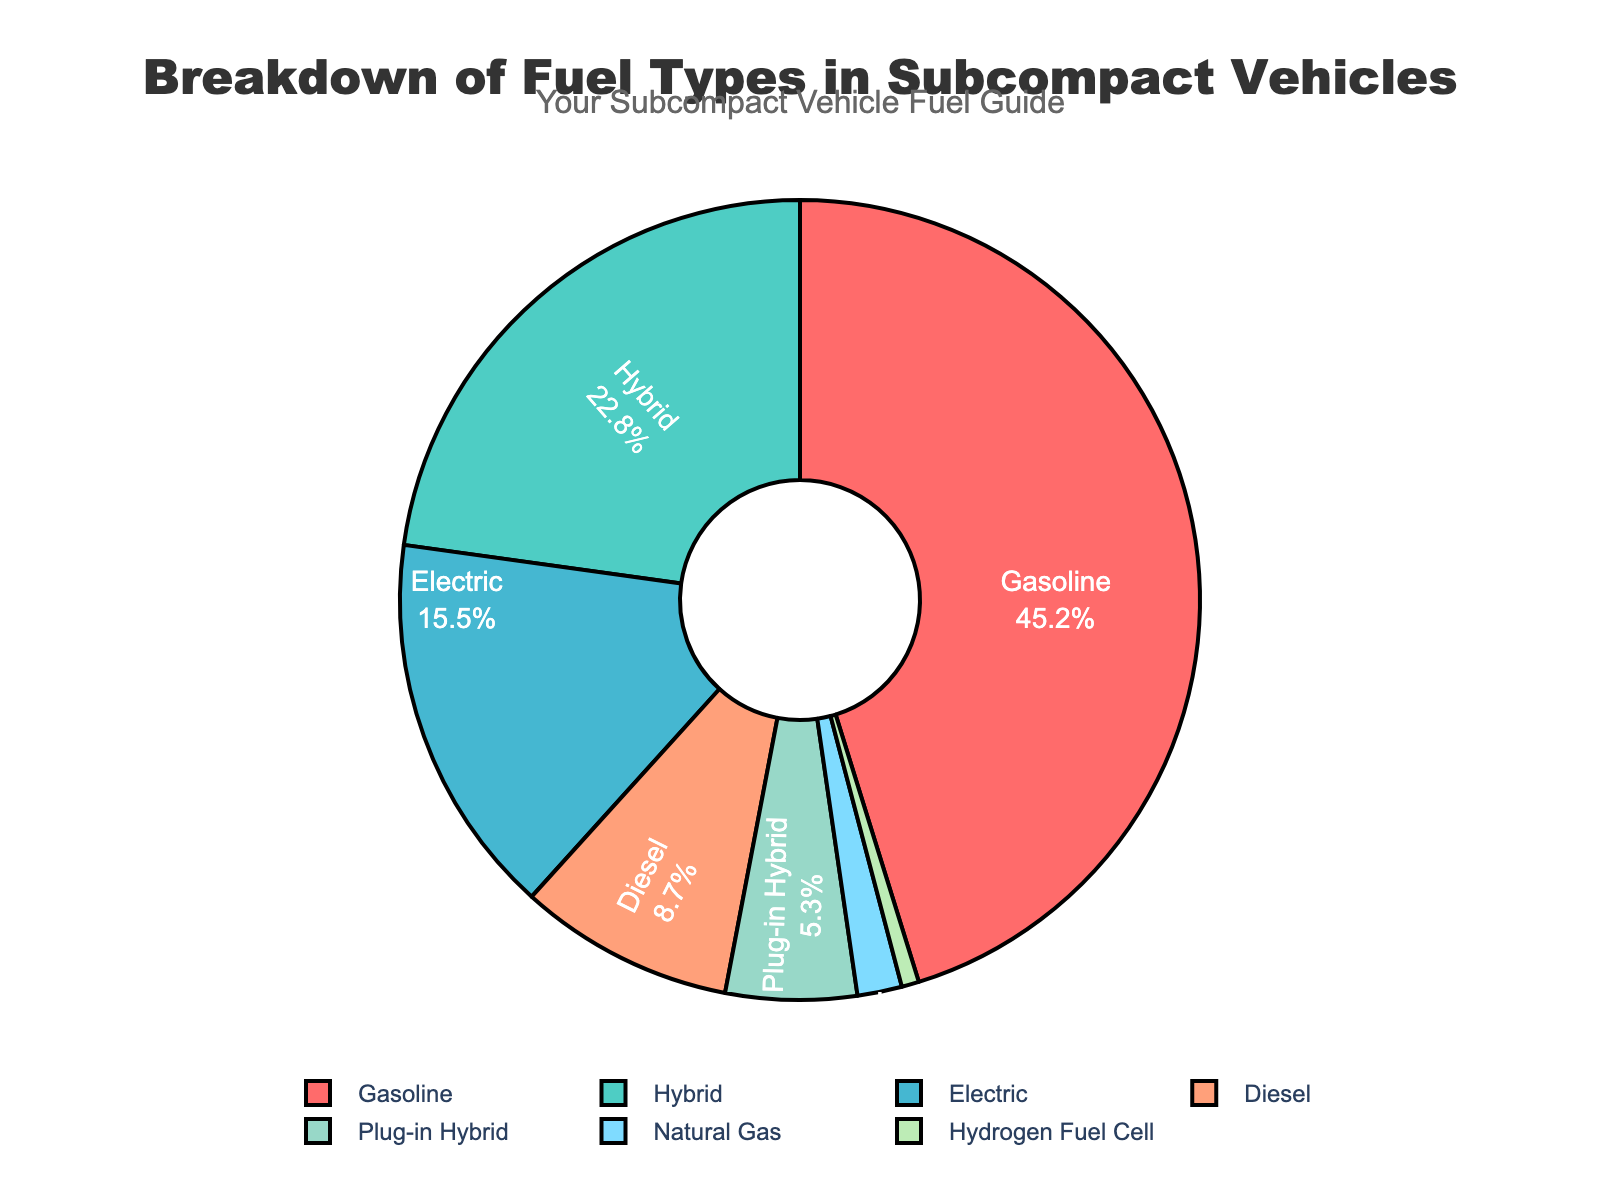what percentage of subcompact vehicles use hybrid or electric fuel types combined? To find the combined percentage of hybrid and electric fuel types, add their individual percentages: 22.8% (Hybrid) + 15.5% (Electric) = 38.3%.
Answer: 38.3% which fuel type is used the least in subcompact vehicles? To determine the least used fuel type, look for the segment with the smallest percentage. Hydrogen Fuel Cell has the smallest percentage at 0.7%.
Answer: Hydrogen Fuel Cell is the percentage of gasoline-powered subcompact vehicles greater than the combined percentage of diesel and plug-in hybrid vehicles? Compare the percentage of gasoline (45.2%) to the combined percentage of diesel (8.7%) and plug-in hybrid (5.3%). Combined percentage: 8.7% + 5.3% = 14%. 45.2% is greater than 14%.
Answer: Yes what is the visual color representing electric vehicles in the pie chart? The electric vehicles are represented by the third color in the custom color palette, which corresponds to a blueish-green color.
Answer: Blueish-green what is the difference in the percentage points between gasoline and natural gas fuel types? Subtract the percentage of natural gas from gasoline: 45.2% - 1.8% = 43.4%.
Answer: 43.4% what combined percentage of subcompact vehicles use alternative fuels (excluding gasoline and diesel)? Add the percentages of alternative fuel types: 22.8% (Hybrid) + 15.5% (Electric) + 5.3% (Plug-in Hybrid) + 1.8% (Natural Gas) + 0.7% (Hydrogen Fuel Cell) = 46.1%.
Answer: 46.1% which two fuel types' combined percentage is closest to half the total percentage of subcompact vehicles? Look for fuel types whose sum is close to 50%. Hybrid (22.8%) and Electric (15.5%) combined is 38.3%, which is closest to half.
Answer: Hybrid and Electric do hydrogen fuel cell vehicles have a larger or smaller percentage than natural gas vehicles? Compare the percentage of Hydrogen Fuel Cell (0.7%) to Natural Gas (1.8%). 0.7% is smaller than 1.8%.
Answer: Smaller what percentage more do gasoline vehicles constitute over hybrid vehicles? Subtract hybrid percentage from gasoline and find the difference: 45.2% - 22.8% = 22.4%.
Answer: 22.4% which fuel type is represented by a salmon-like color in the pie chart? The fifth color in the palette represents Diesel, which is a salmon-like color.
Answer: Diesel 